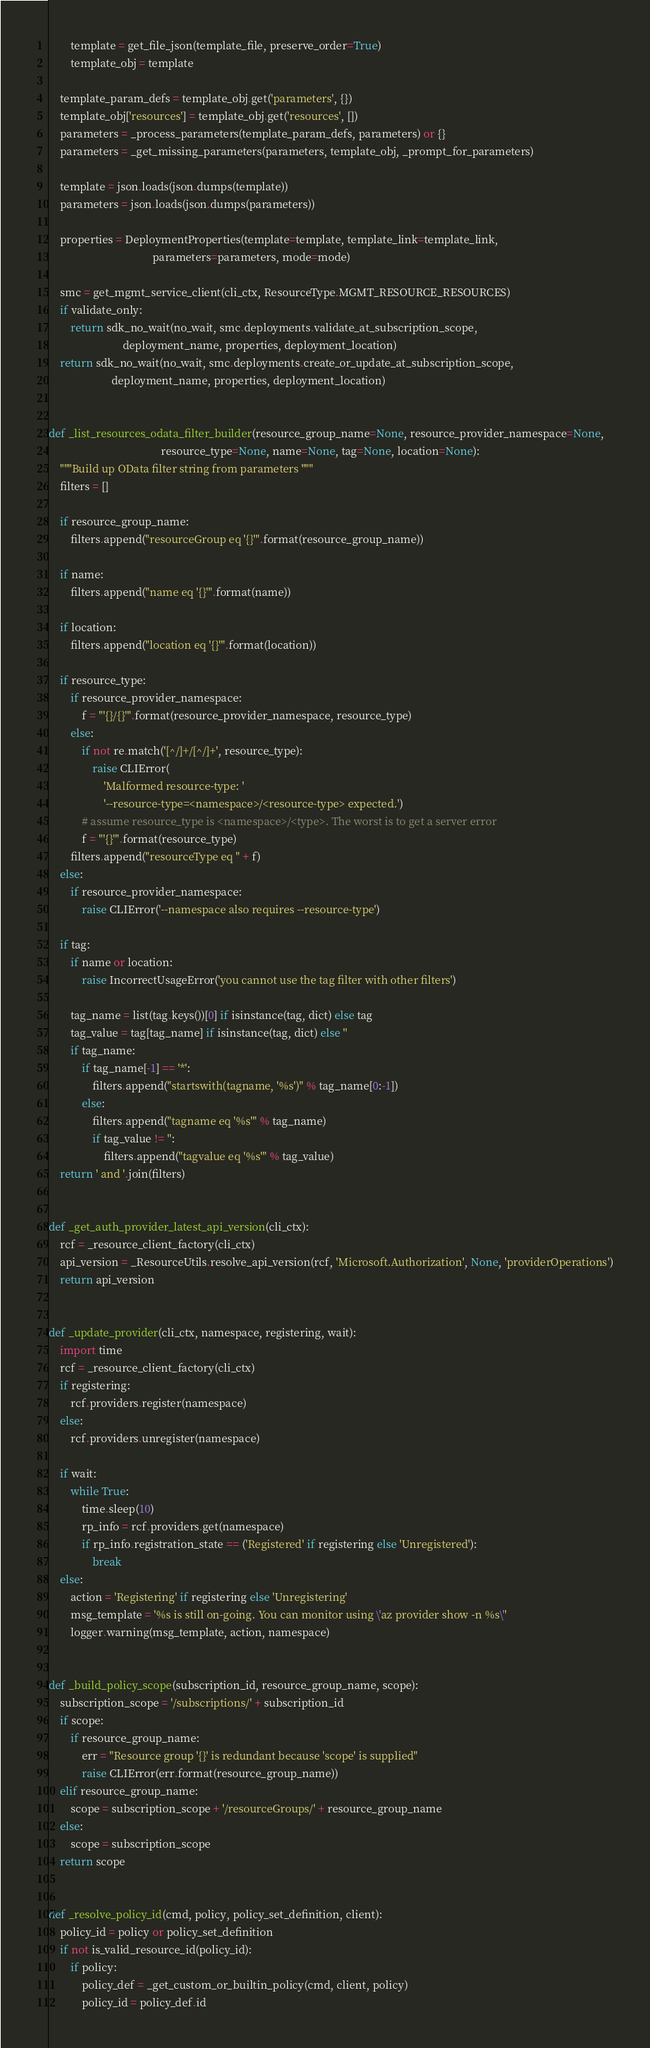<code> <loc_0><loc_0><loc_500><loc_500><_Python_>        template = get_file_json(template_file, preserve_order=True)
        template_obj = template

    template_param_defs = template_obj.get('parameters', {})
    template_obj['resources'] = template_obj.get('resources', [])
    parameters = _process_parameters(template_param_defs, parameters) or {}
    parameters = _get_missing_parameters(parameters, template_obj, _prompt_for_parameters)

    template = json.loads(json.dumps(template))
    parameters = json.loads(json.dumps(parameters))

    properties = DeploymentProperties(template=template, template_link=template_link,
                                      parameters=parameters, mode=mode)

    smc = get_mgmt_service_client(cli_ctx, ResourceType.MGMT_RESOURCE_RESOURCES)
    if validate_only:
        return sdk_no_wait(no_wait, smc.deployments.validate_at_subscription_scope,
                           deployment_name, properties, deployment_location)
    return sdk_no_wait(no_wait, smc.deployments.create_or_update_at_subscription_scope,
                       deployment_name, properties, deployment_location)


def _list_resources_odata_filter_builder(resource_group_name=None, resource_provider_namespace=None,
                                         resource_type=None, name=None, tag=None, location=None):
    """Build up OData filter string from parameters """
    filters = []

    if resource_group_name:
        filters.append("resourceGroup eq '{}'".format(resource_group_name))

    if name:
        filters.append("name eq '{}'".format(name))

    if location:
        filters.append("location eq '{}'".format(location))

    if resource_type:
        if resource_provider_namespace:
            f = "'{}/{}'".format(resource_provider_namespace, resource_type)
        else:
            if not re.match('[^/]+/[^/]+', resource_type):
                raise CLIError(
                    'Malformed resource-type: '
                    '--resource-type=<namespace>/<resource-type> expected.')
            # assume resource_type is <namespace>/<type>. The worst is to get a server error
            f = "'{}'".format(resource_type)
        filters.append("resourceType eq " + f)
    else:
        if resource_provider_namespace:
            raise CLIError('--namespace also requires --resource-type')

    if tag:
        if name or location:
            raise IncorrectUsageError('you cannot use the tag filter with other filters')

        tag_name = list(tag.keys())[0] if isinstance(tag, dict) else tag
        tag_value = tag[tag_name] if isinstance(tag, dict) else ''
        if tag_name:
            if tag_name[-1] == '*':
                filters.append("startswith(tagname, '%s')" % tag_name[0:-1])
            else:
                filters.append("tagname eq '%s'" % tag_name)
                if tag_value != '':
                    filters.append("tagvalue eq '%s'" % tag_value)
    return ' and '.join(filters)


def _get_auth_provider_latest_api_version(cli_ctx):
    rcf = _resource_client_factory(cli_ctx)
    api_version = _ResourceUtils.resolve_api_version(rcf, 'Microsoft.Authorization', None, 'providerOperations')
    return api_version


def _update_provider(cli_ctx, namespace, registering, wait):
    import time
    rcf = _resource_client_factory(cli_ctx)
    if registering:
        rcf.providers.register(namespace)
    else:
        rcf.providers.unregister(namespace)

    if wait:
        while True:
            time.sleep(10)
            rp_info = rcf.providers.get(namespace)
            if rp_info.registration_state == ('Registered' if registering else 'Unregistered'):
                break
    else:
        action = 'Registering' if registering else 'Unregistering'
        msg_template = '%s is still on-going. You can monitor using \'az provider show -n %s\''
        logger.warning(msg_template, action, namespace)


def _build_policy_scope(subscription_id, resource_group_name, scope):
    subscription_scope = '/subscriptions/' + subscription_id
    if scope:
        if resource_group_name:
            err = "Resource group '{}' is redundant because 'scope' is supplied"
            raise CLIError(err.format(resource_group_name))
    elif resource_group_name:
        scope = subscription_scope + '/resourceGroups/' + resource_group_name
    else:
        scope = subscription_scope
    return scope


def _resolve_policy_id(cmd, policy, policy_set_definition, client):
    policy_id = policy or policy_set_definition
    if not is_valid_resource_id(policy_id):
        if policy:
            policy_def = _get_custom_or_builtin_policy(cmd, client, policy)
            policy_id = policy_def.id</code> 